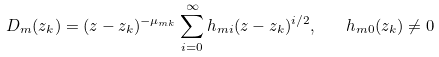<formula> <loc_0><loc_0><loc_500><loc_500>D _ { m } ( z _ { k } ) = ( z - z _ { k } ) ^ { - \mu _ { m k } } \sum ^ { \infty } _ { i = 0 } { h _ { m i } ( z - z _ { k } ) ^ { i / 2 } } , \quad h _ { m 0 } ( z _ { k } ) \neq 0</formula> 